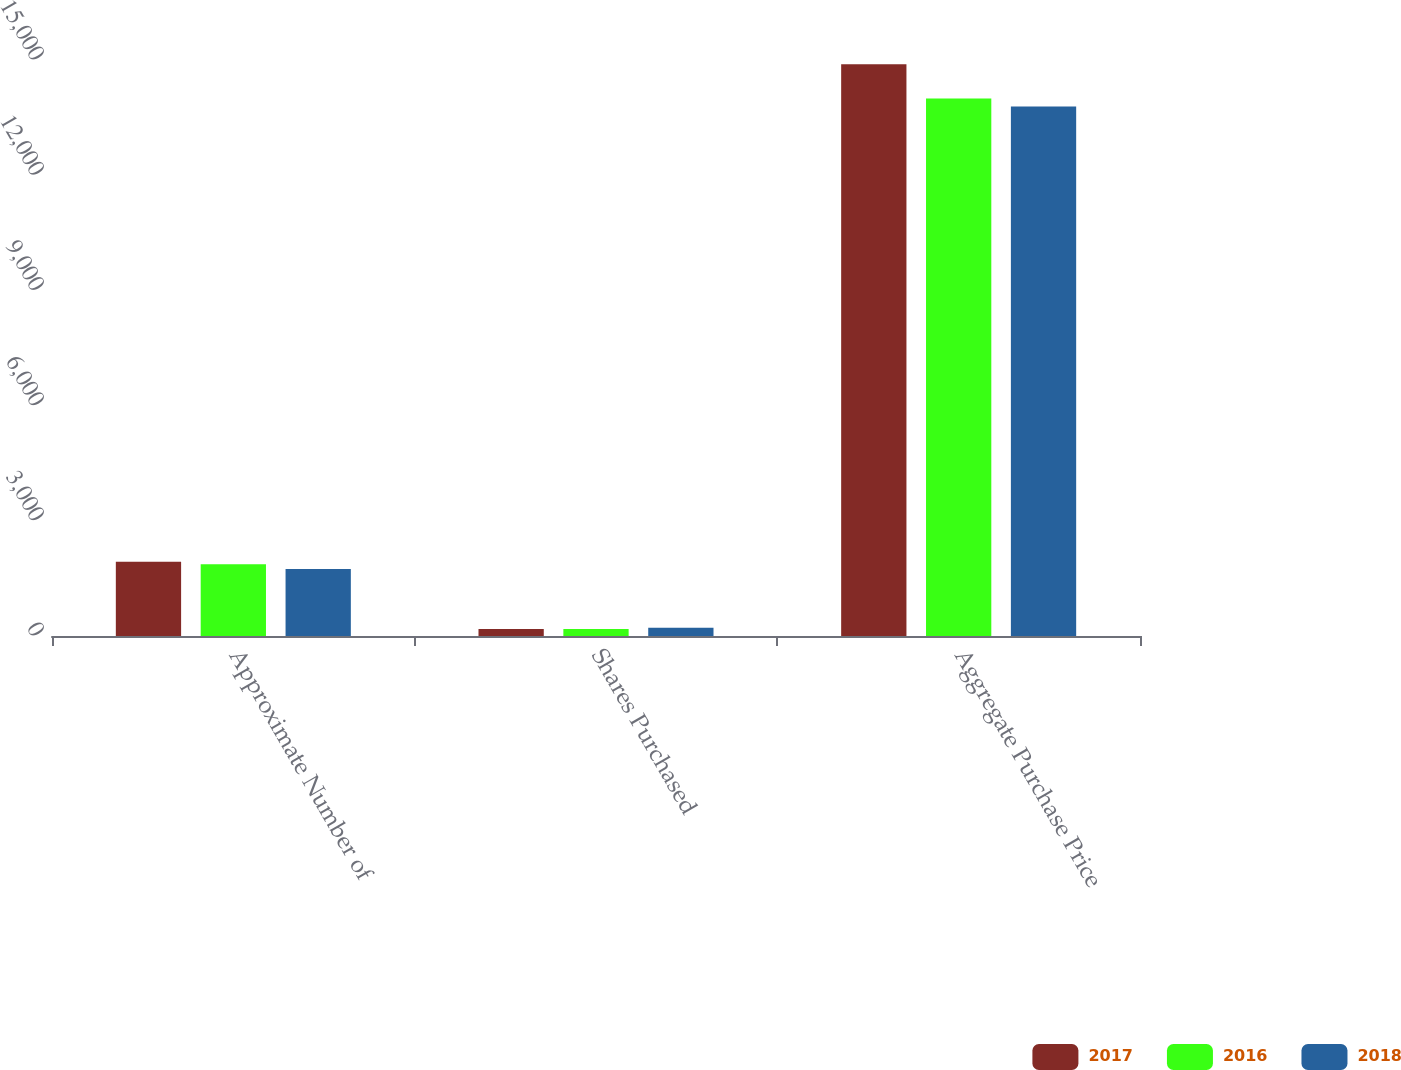Convert chart. <chart><loc_0><loc_0><loc_500><loc_500><stacked_bar_chart><ecel><fcel>Approximate Number of<fcel>Shares Purchased<fcel>Aggregate Purchase Price<nl><fcel>2017<fcel>1934<fcel>180<fcel>14887<nl><fcel>2016<fcel>1870<fcel>180<fcel>13997<nl><fcel>2018<fcel>1746<fcel>212<fcel>13787<nl></chart> 